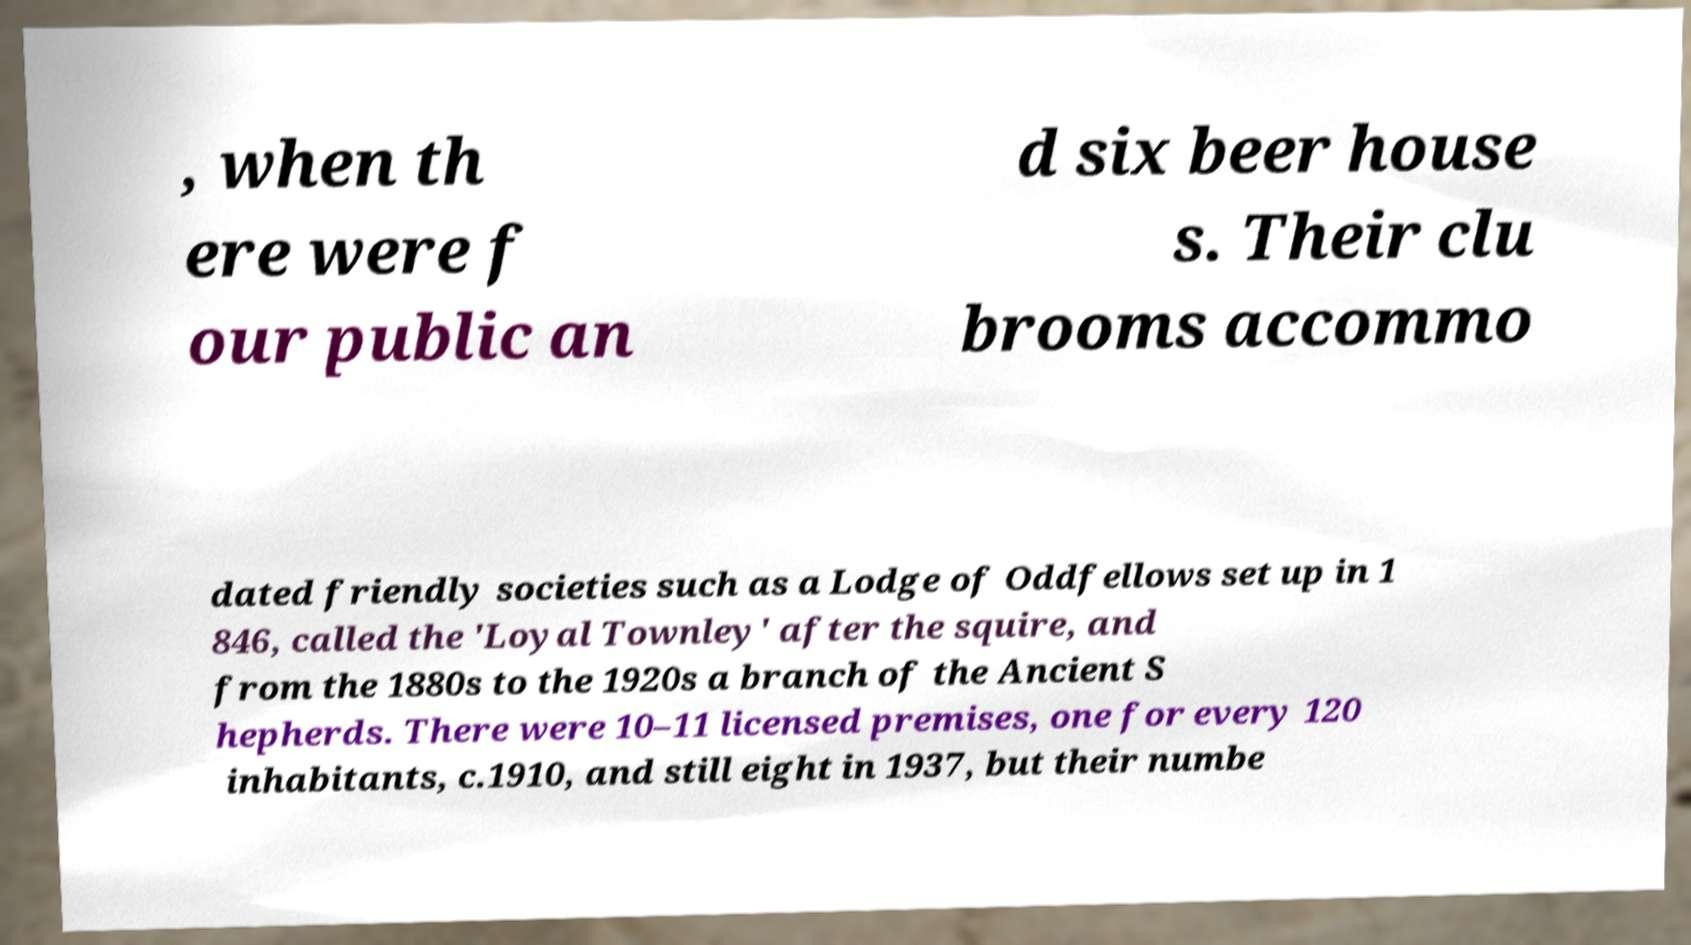There's text embedded in this image that I need extracted. Can you transcribe it verbatim? , when th ere were f our public an d six beer house s. Their clu brooms accommo dated friendly societies such as a Lodge of Oddfellows set up in 1 846, called the 'Loyal Townley' after the squire, and from the 1880s to the 1920s a branch of the Ancient S hepherds. There were 10–11 licensed premises, one for every 120 inhabitants, c.1910, and still eight in 1937, but their numbe 